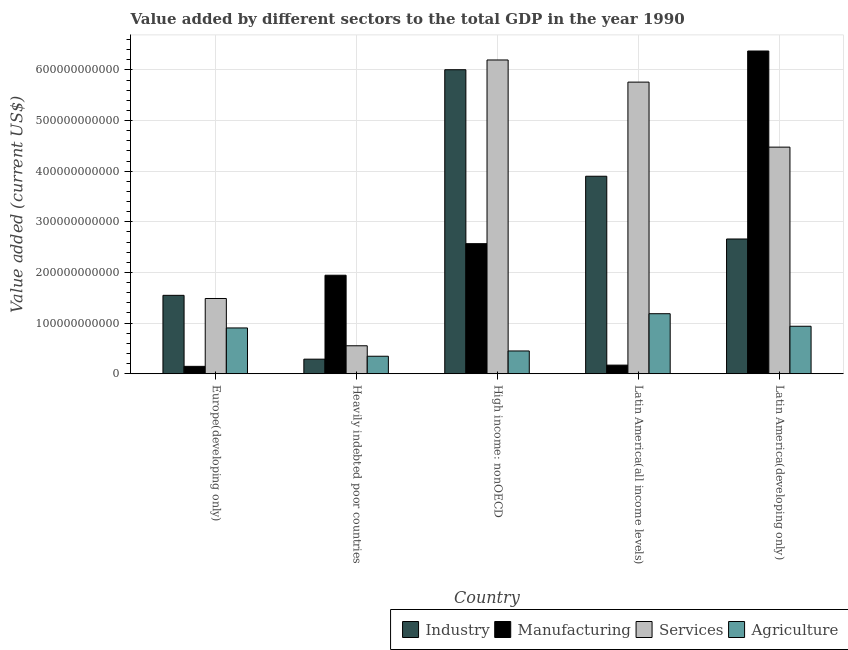How many different coloured bars are there?
Ensure brevity in your answer.  4. How many bars are there on the 5th tick from the left?
Keep it short and to the point. 4. How many bars are there on the 4th tick from the right?
Ensure brevity in your answer.  4. What is the label of the 4th group of bars from the left?
Provide a short and direct response. Latin America(all income levels). In how many cases, is the number of bars for a given country not equal to the number of legend labels?
Your response must be concise. 0. What is the value added by industrial sector in Europe(developing only)?
Give a very brief answer. 1.55e+11. Across all countries, what is the maximum value added by services sector?
Your answer should be very brief. 6.20e+11. Across all countries, what is the minimum value added by manufacturing sector?
Your answer should be very brief. 1.46e+1. In which country was the value added by agricultural sector maximum?
Provide a short and direct response. Latin America(all income levels). In which country was the value added by agricultural sector minimum?
Ensure brevity in your answer.  Heavily indebted poor countries. What is the total value added by agricultural sector in the graph?
Your answer should be compact. 3.82e+11. What is the difference between the value added by services sector in Europe(developing only) and that in High income: nonOECD?
Keep it short and to the point. -4.71e+11. What is the difference between the value added by industrial sector in Latin America(all income levels) and the value added by agricultural sector in Latin America(developing only)?
Your answer should be compact. 2.96e+11. What is the average value added by industrial sector per country?
Offer a terse response. 2.88e+11. What is the difference between the value added by industrial sector and value added by agricultural sector in High income: nonOECD?
Your answer should be compact. 5.56e+11. What is the ratio of the value added by agricultural sector in High income: nonOECD to that in Latin America(all income levels)?
Ensure brevity in your answer.  0.38. Is the value added by services sector in High income: nonOECD less than that in Latin America(developing only)?
Make the answer very short. No. Is the difference between the value added by services sector in Europe(developing only) and Heavily indebted poor countries greater than the difference between the value added by agricultural sector in Europe(developing only) and Heavily indebted poor countries?
Ensure brevity in your answer.  Yes. What is the difference between the highest and the second highest value added by manufacturing sector?
Ensure brevity in your answer.  3.81e+11. What is the difference between the highest and the lowest value added by manufacturing sector?
Your answer should be very brief. 6.23e+11. In how many countries, is the value added by agricultural sector greater than the average value added by agricultural sector taken over all countries?
Your answer should be compact. 3. Is the sum of the value added by services sector in High income: nonOECD and Latin America(all income levels) greater than the maximum value added by industrial sector across all countries?
Give a very brief answer. Yes. What does the 1st bar from the left in Latin America(all income levels) represents?
Offer a terse response. Industry. What does the 2nd bar from the right in Heavily indebted poor countries represents?
Provide a succinct answer. Services. Is it the case that in every country, the sum of the value added by industrial sector and value added by manufacturing sector is greater than the value added by services sector?
Your answer should be compact. No. How many bars are there?
Ensure brevity in your answer.  20. What is the difference between two consecutive major ticks on the Y-axis?
Offer a very short reply. 1.00e+11. Does the graph contain any zero values?
Provide a succinct answer. No. How many legend labels are there?
Your answer should be very brief. 4. How are the legend labels stacked?
Your answer should be very brief. Horizontal. What is the title of the graph?
Offer a very short reply. Value added by different sectors to the total GDP in the year 1990. What is the label or title of the X-axis?
Give a very brief answer. Country. What is the label or title of the Y-axis?
Offer a terse response. Value added (current US$). What is the Value added (current US$) of Industry in Europe(developing only)?
Make the answer very short. 1.55e+11. What is the Value added (current US$) of Manufacturing in Europe(developing only)?
Your response must be concise. 1.46e+1. What is the Value added (current US$) in Services in Europe(developing only)?
Give a very brief answer. 1.49e+11. What is the Value added (current US$) of Agriculture in Europe(developing only)?
Give a very brief answer. 9.04e+1. What is the Value added (current US$) in Industry in Heavily indebted poor countries?
Offer a very short reply. 2.88e+1. What is the Value added (current US$) in Manufacturing in Heavily indebted poor countries?
Your answer should be compact. 1.95e+11. What is the Value added (current US$) in Services in Heavily indebted poor countries?
Your answer should be very brief. 5.52e+1. What is the Value added (current US$) of Agriculture in Heavily indebted poor countries?
Offer a very short reply. 3.46e+1. What is the Value added (current US$) of Industry in High income: nonOECD?
Give a very brief answer. 6.01e+11. What is the Value added (current US$) in Manufacturing in High income: nonOECD?
Your response must be concise. 2.57e+11. What is the Value added (current US$) in Services in High income: nonOECD?
Your answer should be compact. 6.20e+11. What is the Value added (current US$) of Agriculture in High income: nonOECD?
Provide a short and direct response. 4.50e+1. What is the Value added (current US$) in Industry in Latin America(all income levels)?
Offer a very short reply. 3.90e+11. What is the Value added (current US$) of Manufacturing in Latin America(all income levels)?
Make the answer very short. 1.70e+1. What is the Value added (current US$) in Services in Latin America(all income levels)?
Keep it short and to the point. 5.76e+11. What is the Value added (current US$) of Agriculture in Latin America(all income levels)?
Your answer should be very brief. 1.19e+11. What is the Value added (current US$) of Industry in Latin America(developing only)?
Give a very brief answer. 2.66e+11. What is the Value added (current US$) in Manufacturing in Latin America(developing only)?
Offer a terse response. 6.38e+11. What is the Value added (current US$) in Services in Latin America(developing only)?
Offer a very short reply. 4.48e+11. What is the Value added (current US$) of Agriculture in Latin America(developing only)?
Ensure brevity in your answer.  9.38e+1. Across all countries, what is the maximum Value added (current US$) of Industry?
Your response must be concise. 6.01e+11. Across all countries, what is the maximum Value added (current US$) of Manufacturing?
Your response must be concise. 6.38e+11. Across all countries, what is the maximum Value added (current US$) in Services?
Your answer should be very brief. 6.20e+11. Across all countries, what is the maximum Value added (current US$) in Agriculture?
Provide a short and direct response. 1.19e+11. Across all countries, what is the minimum Value added (current US$) in Industry?
Your response must be concise. 2.88e+1. Across all countries, what is the minimum Value added (current US$) of Manufacturing?
Offer a very short reply. 1.46e+1. Across all countries, what is the minimum Value added (current US$) in Services?
Offer a very short reply. 5.52e+1. Across all countries, what is the minimum Value added (current US$) of Agriculture?
Keep it short and to the point. 3.46e+1. What is the total Value added (current US$) of Industry in the graph?
Provide a succinct answer. 1.44e+12. What is the total Value added (current US$) of Manufacturing in the graph?
Your response must be concise. 1.12e+12. What is the total Value added (current US$) of Services in the graph?
Provide a succinct answer. 1.85e+12. What is the total Value added (current US$) in Agriculture in the graph?
Offer a very short reply. 3.82e+11. What is the difference between the Value added (current US$) of Industry in Europe(developing only) and that in Heavily indebted poor countries?
Your response must be concise. 1.26e+11. What is the difference between the Value added (current US$) of Manufacturing in Europe(developing only) and that in Heavily indebted poor countries?
Make the answer very short. -1.80e+11. What is the difference between the Value added (current US$) in Services in Europe(developing only) and that in Heavily indebted poor countries?
Offer a very short reply. 9.34e+1. What is the difference between the Value added (current US$) of Agriculture in Europe(developing only) and that in Heavily indebted poor countries?
Keep it short and to the point. 5.59e+1. What is the difference between the Value added (current US$) in Industry in Europe(developing only) and that in High income: nonOECD?
Offer a very short reply. -4.46e+11. What is the difference between the Value added (current US$) in Manufacturing in Europe(developing only) and that in High income: nonOECD?
Provide a short and direct response. -2.42e+11. What is the difference between the Value added (current US$) of Services in Europe(developing only) and that in High income: nonOECD?
Give a very brief answer. -4.71e+11. What is the difference between the Value added (current US$) of Agriculture in Europe(developing only) and that in High income: nonOECD?
Offer a very short reply. 4.55e+1. What is the difference between the Value added (current US$) in Industry in Europe(developing only) and that in Latin America(all income levels)?
Provide a short and direct response. -2.35e+11. What is the difference between the Value added (current US$) in Manufacturing in Europe(developing only) and that in Latin America(all income levels)?
Make the answer very short. -2.43e+09. What is the difference between the Value added (current US$) of Services in Europe(developing only) and that in Latin America(all income levels)?
Provide a short and direct response. -4.27e+11. What is the difference between the Value added (current US$) in Agriculture in Europe(developing only) and that in Latin America(all income levels)?
Provide a succinct answer. -2.81e+1. What is the difference between the Value added (current US$) in Industry in Europe(developing only) and that in Latin America(developing only)?
Offer a terse response. -1.11e+11. What is the difference between the Value added (current US$) of Manufacturing in Europe(developing only) and that in Latin America(developing only)?
Give a very brief answer. -6.23e+11. What is the difference between the Value added (current US$) of Services in Europe(developing only) and that in Latin America(developing only)?
Your response must be concise. -2.99e+11. What is the difference between the Value added (current US$) in Agriculture in Europe(developing only) and that in Latin America(developing only)?
Your answer should be compact. -3.35e+09. What is the difference between the Value added (current US$) in Industry in Heavily indebted poor countries and that in High income: nonOECD?
Keep it short and to the point. -5.72e+11. What is the difference between the Value added (current US$) in Manufacturing in Heavily indebted poor countries and that in High income: nonOECD?
Provide a short and direct response. -6.23e+1. What is the difference between the Value added (current US$) in Services in Heavily indebted poor countries and that in High income: nonOECD?
Make the answer very short. -5.65e+11. What is the difference between the Value added (current US$) in Agriculture in Heavily indebted poor countries and that in High income: nonOECD?
Your answer should be compact. -1.04e+1. What is the difference between the Value added (current US$) in Industry in Heavily indebted poor countries and that in Latin America(all income levels)?
Make the answer very short. -3.61e+11. What is the difference between the Value added (current US$) in Manufacturing in Heavily indebted poor countries and that in Latin America(all income levels)?
Your response must be concise. 1.78e+11. What is the difference between the Value added (current US$) of Services in Heavily indebted poor countries and that in Latin America(all income levels)?
Make the answer very short. -5.21e+11. What is the difference between the Value added (current US$) of Agriculture in Heavily indebted poor countries and that in Latin America(all income levels)?
Offer a terse response. -8.40e+1. What is the difference between the Value added (current US$) in Industry in Heavily indebted poor countries and that in Latin America(developing only)?
Give a very brief answer. -2.37e+11. What is the difference between the Value added (current US$) in Manufacturing in Heavily indebted poor countries and that in Latin America(developing only)?
Provide a short and direct response. -4.43e+11. What is the difference between the Value added (current US$) in Services in Heavily indebted poor countries and that in Latin America(developing only)?
Provide a succinct answer. -3.92e+11. What is the difference between the Value added (current US$) in Agriculture in Heavily indebted poor countries and that in Latin America(developing only)?
Your response must be concise. -5.92e+1. What is the difference between the Value added (current US$) of Industry in High income: nonOECD and that in Latin America(all income levels)?
Offer a very short reply. 2.10e+11. What is the difference between the Value added (current US$) of Manufacturing in High income: nonOECD and that in Latin America(all income levels)?
Provide a short and direct response. 2.40e+11. What is the difference between the Value added (current US$) in Services in High income: nonOECD and that in Latin America(all income levels)?
Offer a terse response. 4.37e+1. What is the difference between the Value added (current US$) of Agriculture in High income: nonOECD and that in Latin America(all income levels)?
Your answer should be very brief. -7.36e+1. What is the difference between the Value added (current US$) in Industry in High income: nonOECD and that in Latin America(developing only)?
Your answer should be compact. 3.34e+11. What is the difference between the Value added (current US$) in Manufacturing in High income: nonOECD and that in Latin America(developing only)?
Offer a very short reply. -3.81e+11. What is the difference between the Value added (current US$) in Services in High income: nonOECD and that in Latin America(developing only)?
Make the answer very short. 1.72e+11. What is the difference between the Value added (current US$) of Agriculture in High income: nonOECD and that in Latin America(developing only)?
Offer a terse response. -4.88e+1. What is the difference between the Value added (current US$) in Industry in Latin America(all income levels) and that in Latin America(developing only)?
Keep it short and to the point. 1.24e+11. What is the difference between the Value added (current US$) in Manufacturing in Latin America(all income levels) and that in Latin America(developing only)?
Your answer should be very brief. -6.20e+11. What is the difference between the Value added (current US$) in Services in Latin America(all income levels) and that in Latin America(developing only)?
Provide a short and direct response. 1.28e+11. What is the difference between the Value added (current US$) of Agriculture in Latin America(all income levels) and that in Latin America(developing only)?
Offer a very short reply. 2.48e+1. What is the difference between the Value added (current US$) of Industry in Europe(developing only) and the Value added (current US$) of Manufacturing in Heavily indebted poor countries?
Provide a succinct answer. -3.97e+1. What is the difference between the Value added (current US$) in Industry in Europe(developing only) and the Value added (current US$) in Services in Heavily indebted poor countries?
Provide a short and direct response. 9.96e+1. What is the difference between the Value added (current US$) in Industry in Europe(developing only) and the Value added (current US$) in Agriculture in Heavily indebted poor countries?
Ensure brevity in your answer.  1.20e+11. What is the difference between the Value added (current US$) in Manufacturing in Europe(developing only) and the Value added (current US$) in Services in Heavily indebted poor countries?
Your response must be concise. -4.06e+1. What is the difference between the Value added (current US$) of Manufacturing in Europe(developing only) and the Value added (current US$) of Agriculture in Heavily indebted poor countries?
Offer a terse response. -2.00e+1. What is the difference between the Value added (current US$) of Services in Europe(developing only) and the Value added (current US$) of Agriculture in Heavily indebted poor countries?
Give a very brief answer. 1.14e+11. What is the difference between the Value added (current US$) of Industry in Europe(developing only) and the Value added (current US$) of Manufacturing in High income: nonOECD?
Give a very brief answer. -1.02e+11. What is the difference between the Value added (current US$) of Industry in Europe(developing only) and the Value added (current US$) of Services in High income: nonOECD?
Keep it short and to the point. -4.65e+11. What is the difference between the Value added (current US$) in Industry in Europe(developing only) and the Value added (current US$) in Agriculture in High income: nonOECD?
Keep it short and to the point. 1.10e+11. What is the difference between the Value added (current US$) in Manufacturing in Europe(developing only) and the Value added (current US$) in Services in High income: nonOECD?
Give a very brief answer. -6.05e+11. What is the difference between the Value added (current US$) of Manufacturing in Europe(developing only) and the Value added (current US$) of Agriculture in High income: nonOECD?
Your answer should be compact. -3.04e+1. What is the difference between the Value added (current US$) of Services in Europe(developing only) and the Value added (current US$) of Agriculture in High income: nonOECD?
Your answer should be compact. 1.04e+11. What is the difference between the Value added (current US$) in Industry in Europe(developing only) and the Value added (current US$) in Manufacturing in Latin America(all income levels)?
Your answer should be very brief. 1.38e+11. What is the difference between the Value added (current US$) in Industry in Europe(developing only) and the Value added (current US$) in Services in Latin America(all income levels)?
Make the answer very short. -4.21e+11. What is the difference between the Value added (current US$) of Industry in Europe(developing only) and the Value added (current US$) of Agriculture in Latin America(all income levels)?
Make the answer very short. 3.63e+1. What is the difference between the Value added (current US$) of Manufacturing in Europe(developing only) and the Value added (current US$) of Services in Latin America(all income levels)?
Give a very brief answer. -5.61e+11. What is the difference between the Value added (current US$) of Manufacturing in Europe(developing only) and the Value added (current US$) of Agriculture in Latin America(all income levels)?
Offer a very short reply. -1.04e+11. What is the difference between the Value added (current US$) of Services in Europe(developing only) and the Value added (current US$) of Agriculture in Latin America(all income levels)?
Make the answer very short. 3.01e+1. What is the difference between the Value added (current US$) of Industry in Europe(developing only) and the Value added (current US$) of Manufacturing in Latin America(developing only)?
Your answer should be very brief. -4.83e+11. What is the difference between the Value added (current US$) of Industry in Europe(developing only) and the Value added (current US$) of Services in Latin America(developing only)?
Ensure brevity in your answer.  -2.93e+11. What is the difference between the Value added (current US$) of Industry in Europe(developing only) and the Value added (current US$) of Agriculture in Latin America(developing only)?
Ensure brevity in your answer.  6.11e+1. What is the difference between the Value added (current US$) in Manufacturing in Europe(developing only) and the Value added (current US$) in Services in Latin America(developing only)?
Provide a short and direct response. -4.33e+11. What is the difference between the Value added (current US$) of Manufacturing in Europe(developing only) and the Value added (current US$) of Agriculture in Latin America(developing only)?
Your answer should be compact. -7.92e+1. What is the difference between the Value added (current US$) of Services in Europe(developing only) and the Value added (current US$) of Agriculture in Latin America(developing only)?
Make the answer very short. 5.48e+1. What is the difference between the Value added (current US$) in Industry in Heavily indebted poor countries and the Value added (current US$) in Manufacturing in High income: nonOECD?
Give a very brief answer. -2.28e+11. What is the difference between the Value added (current US$) of Industry in Heavily indebted poor countries and the Value added (current US$) of Services in High income: nonOECD?
Make the answer very short. -5.91e+11. What is the difference between the Value added (current US$) of Industry in Heavily indebted poor countries and the Value added (current US$) of Agriculture in High income: nonOECD?
Make the answer very short. -1.62e+1. What is the difference between the Value added (current US$) in Manufacturing in Heavily indebted poor countries and the Value added (current US$) in Services in High income: nonOECD?
Your answer should be compact. -4.25e+11. What is the difference between the Value added (current US$) of Manufacturing in Heavily indebted poor countries and the Value added (current US$) of Agriculture in High income: nonOECD?
Keep it short and to the point. 1.50e+11. What is the difference between the Value added (current US$) of Services in Heavily indebted poor countries and the Value added (current US$) of Agriculture in High income: nonOECD?
Your answer should be very brief. 1.02e+1. What is the difference between the Value added (current US$) of Industry in Heavily indebted poor countries and the Value added (current US$) of Manufacturing in Latin America(all income levels)?
Make the answer very short. 1.17e+1. What is the difference between the Value added (current US$) of Industry in Heavily indebted poor countries and the Value added (current US$) of Services in Latin America(all income levels)?
Ensure brevity in your answer.  -5.47e+11. What is the difference between the Value added (current US$) of Industry in Heavily indebted poor countries and the Value added (current US$) of Agriculture in Latin America(all income levels)?
Offer a terse response. -8.98e+1. What is the difference between the Value added (current US$) in Manufacturing in Heavily indebted poor countries and the Value added (current US$) in Services in Latin America(all income levels)?
Offer a terse response. -3.81e+11. What is the difference between the Value added (current US$) in Manufacturing in Heavily indebted poor countries and the Value added (current US$) in Agriculture in Latin America(all income levels)?
Ensure brevity in your answer.  7.60e+1. What is the difference between the Value added (current US$) in Services in Heavily indebted poor countries and the Value added (current US$) in Agriculture in Latin America(all income levels)?
Provide a short and direct response. -6.33e+1. What is the difference between the Value added (current US$) in Industry in Heavily indebted poor countries and the Value added (current US$) in Manufacturing in Latin America(developing only)?
Offer a terse response. -6.09e+11. What is the difference between the Value added (current US$) in Industry in Heavily indebted poor countries and the Value added (current US$) in Services in Latin America(developing only)?
Offer a very short reply. -4.19e+11. What is the difference between the Value added (current US$) of Industry in Heavily indebted poor countries and the Value added (current US$) of Agriculture in Latin America(developing only)?
Offer a terse response. -6.50e+1. What is the difference between the Value added (current US$) in Manufacturing in Heavily indebted poor countries and the Value added (current US$) in Services in Latin America(developing only)?
Give a very brief answer. -2.53e+11. What is the difference between the Value added (current US$) in Manufacturing in Heavily indebted poor countries and the Value added (current US$) in Agriculture in Latin America(developing only)?
Offer a very short reply. 1.01e+11. What is the difference between the Value added (current US$) of Services in Heavily indebted poor countries and the Value added (current US$) of Agriculture in Latin America(developing only)?
Keep it short and to the point. -3.86e+1. What is the difference between the Value added (current US$) of Industry in High income: nonOECD and the Value added (current US$) of Manufacturing in Latin America(all income levels)?
Offer a terse response. 5.84e+11. What is the difference between the Value added (current US$) of Industry in High income: nonOECD and the Value added (current US$) of Services in Latin America(all income levels)?
Your answer should be compact. 2.45e+1. What is the difference between the Value added (current US$) of Industry in High income: nonOECD and the Value added (current US$) of Agriculture in Latin America(all income levels)?
Your answer should be compact. 4.82e+11. What is the difference between the Value added (current US$) in Manufacturing in High income: nonOECD and the Value added (current US$) in Services in Latin America(all income levels)?
Your answer should be very brief. -3.19e+11. What is the difference between the Value added (current US$) of Manufacturing in High income: nonOECD and the Value added (current US$) of Agriculture in Latin America(all income levels)?
Make the answer very short. 1.38e+11. What is the difference between the Value added (current US$) of Services in High income: nonOECD and the Value added (current US$) of Agriculture in Latin America(all income levels)?
Make the answer very short. 5.01e+11. What is the difference between the Value added (current US$) of Industry in High income: nonOECD and the Value added (current US$) of Manufacturing in Latin America(developing only)?
Keep it short and to the point. -3.70e+1. What is the difference between the Value added (current US$) of Industry in High income: nonOECD and the Value added (current US$) of Services in Latin America(developing only)?
Offer a terse response. 1.53e+11. What is the difference between the Value added (current US$) in Industry in High income: nonOECD and the Value added (current US$) in Agriculture in Latin America(developing only)?
Your answer should be very brief. 5.07e+11. What is the difference between the Value added (current US$) of Manufacturing in High income: nonOECD and the Value added (current US$) of Services in Latin America(developing only)?
Make the answer very short. -1.91e+11. What is the difference between the Value added (current US$) of Manufacturing in High income: nonOECD and the Value added (current US$) of Agriculture in Latin America(developing only)?
Your answer should be compact. 1.63e+11. What is the difference between the Value added (current US$) of Services in High income: nonOECD and the Value added (current US$) of Agriculture in Latin America(developing only)?
Your response must be concise. 5.26e+11. What is the difference between the Value added (current US$) in Industry in Latin America(all income levels) and the Value added (current US$) in Manufacturing in Latin America(developing only)?
Your answer should be very brief. -2.47e+11. What is the difference between the Value added (current US$) in Industry in Latin America(all income levels) and the Value added (current US$) in Services in Latin America(developing only)?
Offer a terse response. -5.75e+1. What is the difference between the Value added (current US$) of Industry in Latin America(all income levels) and the Value added (current US$) of Agriculture in Latin America(developing only)?
Your response must be concise. 2.96e+11. What is the difference between the Value added (current US$) of Manufacturing in Latin America(all income levels) and the Value added (current US$) of Services in Latin America(developing only)?
Provide a short and direct response. -4.31e+11. What is the difference between the Value added (current US$) in Manufacturing in Latin America(all income levels) and the Value added (current US$) in Agriculture in Latin America(developing only)?
Provide a succinct answer. -7.68e+1. What is the difference between the Value added (current US$) of Services in Latin America(all income levels) and the Value added (current US$) of Agriculture in Latin America(developing only)?
Provide a short and direct response. 4.82e+11. What is the average Value added (current US$) in Industry per country?
Make the answer very short. 2.88e+11. What is the average Value added (current US$) of Manufacturing per country?
Ensure brevity in your answer.  2.24e+11. What is the average Value added (current US$) in Services per country?
Give a very brief answer. 3.69e+11. What is the average Value added (current US$) in Agriculture per country?
Your answer should be compact. 7.65e+1. What is the difference between the Value added (current US$) of Industry and Value added (current US$) of Manufacturing in Europe(developing only)?
Provide a succinct answer. 1.40e+11. What is the difference between the Value added (current US$) of Industry and Value added (current US$) of Services in Europe(developing only)?
Ensure brevity in your answer.  6.23e+09. What is the difference between the Value added (current US$) of Industry and Value added (current US$) of Agriculture in Europe(developing only)?
Provide a succinct answer. 6.44e+1. What is the difference between the Value added (current US$) in Manufacturing and Value added (current US$) in Services in Europe(developing only)?
Keep it short and to the point. -1.34e+11. What is the difference between the Value added (current US$) in Manufacturing and Value added (current US$) in Agriculture in Europe(developing only)?
Provide a succinct answer. -7.58e+1. What is the difference between the Value added (current US$) of Services and Value added (current US$) of Agriculture in Europe(developing only)?
Your answer should be very brief. 5.82e+1. What is the difference between the Value added (current US$) in Industry and Value added (current US$) in Manufacturing in Heavily indebted poor countries?
Make the answer very short. -1.66e+11. What is the difference between the Value added (current US$) of Industry and Value added (current US$) of Services in Heavily indebted poor countries?
Make the answer very short. -2.65e+1. What is the difference between the Value added (current US$) in Industry and Value added (current US$) in Agriculture in Heavily indebted poor countries?
Ensure brevity in your answer.  -5.79e+09. What is the difference between the Value added (current US$) in Manufacturing and Value added (current US$) in Services in Heavily indebted poor countries?
Your answer should be compact. 1.39e+11. What is the difference between the Value added (current US$) of Manufacturing and Value added (current US$) of Agriculture in Heavily indebted poor countries?
Provide a short and direct response. 1.60e+11. What is the difference between the Value added (current US$) in Services and Value added (current US$) in Agriculture in Heavily indebted poor countries?
Keep it short and to the point. 2.07e+1. What is the difference between the Value added (current US$) of Industry and Value added (current US$) of Manufacturing in High income: nonOECD?
Your response must be concise. 3.44e+11. What is the difference between the Value added (current US$) of Industry and Value added (current US$) of Services in High income: nonOECD?
Your answer should be very brief. -1.93e+1. What is the difference between the Value added (current US$) in Industry and Value added (current US$) in Agriculture in High income: nonOECD?
Provide a short and direct response. 5.56e+11. What is the difference between the Value added (current US$) of Manufacturing and Value added (current US$) of Services in High income: nonOECD?
Keep it short and to the point. -3.63e+11. What is the difference between the Value added (current US$) of Manufacturing and Value added (current US$) of Agriculture in High income: nonOECD?
Ensure brevity in your answer.  2.12e+11. What is the difference between the Value added (current US$) of Services and Value added (current US$) of Agriculture in High income: nonOECD?
Ensure brevity in your answer.  5.75e+11. What is the difference between the Value added (current US$) in Industry and Value added (current US$) in Manufacturing in Latin America(all income levels)?
Your answer should be very brief. 3.73e+11. What is the difference between the Value added (current US$) of Industry and Value added (current US$) of Services in Latin America(all income levels)?
Keep it short and to the point. -1.86e+11. What is the difference between the Value added (current US$) in Industry and Value added (current US$) in Agriculture in Latin America(all income levels)?
Your response must be concise. 2.72e+11. What is the difference between the Value added (current US$) in Manufacturing and Value added (current US$) in Services in Latin America(all income levels)?
Make the answer very short. -5.59e+11. What is the difference between the Value added (current US$) in Manufacturing and Value added (current US$) in Agriculture in Latin America(all income levels)?
Your answer should be compact. -1.02e+11. What is the difference between the Value added (current US$) of Services and Value added (current US$) of Agriculture in Latin America(all income levels)?
Ensure brevity in your answer.  4.57e+11. What is the difference between the Value added (current US$) of Industry and Value added (current US$) of Manufacturing in Latin America(developing only)?
Your response must be concise. -3.71e+11. What is the difference between the Value added (current US$) of Industry and Value added (current US$) of Services in Latin America(developing only)?
Make the answer very short. -1.81e+11. What is the difference between the Value added (current US$) of Industry and Value added (current US$) of Agriculture in Latin America(developing only)?
Give a very brief answer. 1.72e+11. What is the difference between the Value added (current US$) of Manufacturing and Value added (current US$) of Services in Latin America(developing only)?
Ensure brevity in your answer.  1.90e+11. What is the difference between the Value added (current US$) in Manufacturing and Value added (current US$) in Agriculture in Latin America(developing only)?
Your response must be concise. 5.44e+11. What is the difference between the Value added (current US$) in Services and Value added (current US$) in Agriculture in Latin America(developing only)?
Your answer should be compact. 3.54e+11. What is the ratio of the Value added (current US$) of Industry in Europe(developing only) to that in Heavily indebted poor countries?
Your response must be concise. 5.38. What is the ratio of the Value added (current US$) of Manufacturing in Europe(developing only) to that in Heavily indebted poor countries?
Provide a succinct answer. 0.07. What is the ratio of the Value added (current US$) in Services in Europe(developing only) to that in Heavily indebted poor countries?
Ensure brevity in your answer.  2.69. What is the ratio of the Value added (current US$) in Agriculture in Europe(developing only) to that in Heavily indebted poor countries?
Offer a terse response. 2.62. What is the ratio of the Value added (current US$) of Industry in Europe(developing only) to that in High income: nonOECD?
Keep it short and to the point. 0.26. What is the ratio of the Value added (current US$) in Manufacturing in Europe(developing only) to that in High income: nonOECD?
Offer a terse response. 0.06. What is the ratio of the Value added (current US$) in Services in Europe(developing only) to that in High income: nonOECD?
Provide a succinct answer. 0.24. What is the ratio of the Value added (current US$) of Agriculture in Europe(developing only) to that in High income: nonOECD?
Your answer should be very brief. 2.01. What is the ratio of the Value added (current US$) in Industry in Europe(developing only) to that in Latin America(all income levels)?
Keep it short and to the point. 0.4. What is the ratio of the Value added (current US$) in Manufacturing in Europe(developing only) to that in Latin America(all income levels)?
Offer a very short reply. 0.86. What is the ratio of the Value added (current US$) of Services in Europe(developing only) to that in Latin America(all income levels)?
Ensure brevity in your answer.  0.26. What is the ratio of the Value added (current US$) of Agriculture in Europe(developing only) to that in Latin America(all income levels)?
Your answer should be compact. 0.76. What is the ratio of the Value added (current US$) in Industry in Europe(developing only) to that in Latin America(developing only)?
Offer a terse response. 0.58. What is the ratio of the Value added (current US$) in Manufacturing in Europe(developing only) to that in Latin America(developing only)?
Offer a very short reply. 0.02. What is the ratio of the Value added (current US$) in Services in Europe(developing only) to that in Latin America(developing only)?
Your response must be concise. 0.33. What is the ratio of the Value added (current US$) in Agriculture in Europe(developing only) to that in Latin America(developing only)?
Your answer should be very brief. 0.96. What is the ratio of the Value added (current US$) in Industry in Heavily indebted poor countries to that in High income: nonOECD?
Give a very brief answer. 0.05. What is the ratio of the Value added (current US$) of Manufacturing in Heavily indebted poor countries to that in High income: nonOECD?
Give a very brief answer. 0.76. What is the ratio of the Value added (current US$) of Services in Heavily indebted poor countries to that in High income: nonOECD?
Ensure brevity in your answer.  0.09. What is the ratio of the Value added (current US$) of Agriculture in Heavily indebted poor countries to that in High income: nonOECD?
Ensure brevity in your answer.  0.77. What is the ratio of the Value added (current US$) in Industry in Heavily indebted poor countries to that in Latin America(all income levels)?
Offer a terse response. 0.07. What is the ratio of the Value added (current US$) of Manufacturing in Heavily indebted poor countries to that in Latin America(all income levels)?
Provide a short and direct response. 11.43. What is the ratio of the Value added (current US$) of Services in Heavily indebted poor countries to that in Latin America(all income levels)?
Provide a succinct answer. 0.1. What is the ratio of the Value added (current US$) of Agriculture in Heavily indebted poor countries to that in Latin America(all income levels)?
Keep it short and to the point. 0.29. What is the ratio of the Value added (current US$) of Industry in Heavily indebted poor countries to that in Latin America(developing only)?
Ensure brevity in your answer.  0.11. What is the ratio of the Value added (current US$) in Manufacturing in Heavily indebted poor countries to that in Latin America(developing only)?
Provide a succinct answer. 0.31. What is the ratio of the Value added (current US$) of Services in Heavily indebted poor countries to that in Latin America(developing only)?
Provide a short and direct response. 0.12. What is the ratio of the Value added (current US$) of Agriculture in Heavily indebted poor countries to that in Latin America(developing only)?
Give a very brief answer. 0.37. What is the ratio of the Value added (current US$) of Industry in High income: nonOECD to that in Latin America(all income levels)?
Keep it short and to the point. 1.54. What is the ratio of the Value added (current US$) in Manufacturing in High income: nonOECD to that in Latin America(all income levels)?
Your answer should be compact. 15.09. What is the ratio of the Value added (current US$) in Services in High income: nonOECD to that in Latin America(all income levels)?
Keep it short and to the point. 1.08. What is the ratio of the Value added (current US$) of Agriculture in High income: nonOECD to that in Latin America(all income levels)?
Keep it short and to the point. 0.38. What is the ratio of the Value added (current US$) in Industry in High income: nonOECD to that in Latin America(developing only)?
Make the answer very short. 2.26. What is the ratio of the Value added (current US$) of Manufacturing in High income: nonOECD to that in Latin America(developing only)?
Your response must be concise. 0.4. What is the ratio of the Value added (current US$) in Services in High income: nonOECD to that in Latin America(developing only)?
Ensure brevity in your answer.  1.38. What is the ratio of the Value added (current US$) of Agriculture in High income: nonOECD to that in Latin America(developing only)?
Keep it short and to the point. 0.48. What is the ratio of the Value added (current US$) in Industry in Latin America(all income levels) to that in Latin America(developing only)?
Give a very brief answer. 1.47. What is the ratio of the Value added (current US$) of Manufacturing in Latin America(all income levels) to that in Latin America(developing only)?
Ensure brevity in your answer.  0.03. What is the ratio of the Value added (current US$) in Services in Latin America(all income levels) to that in Latin America(developing only)?
Your response must be concise. 1.29. What is the ratio of the Value added (current US$) in Agriculture in Latin America(all income levels) to that in Latin America(developing only)?
Your answer should be very brief. 1.26. What is the difference between the highest and the second highest Value added (current US$) of Industry?
Provide a short and direct response. 2.10e+11. What is the difference between the highest and the second highest Value added (current US$) of Manufacturing?
Provide a short and direct response. 3.81e+11. What is the difference between the highest and the second highest Value added (current US$) of Services?
Your answer should be compact. 4.37e+1. What is the difference between the highest and the second highest Value added (current US$) of Agriculture?
Provide a short and direct response. 2.48e+1. What is the difference between the highest and the lowest Value added (current US$) of Industry?
Your answer should be compact. 5.72e+11. What is the difference between the highest and the lowest Value added (current US$) in Manufacturing?
Give a very brief answer. 6.23e+11. What is the difference between the highest and the lowest Value added (current US$) in Services?
Offer a terse response. 5.65e+11. What is the difference between the highest and the lowest Value added (current US$) in Agriculture?
Offer a terse response. 8.40e+1. 